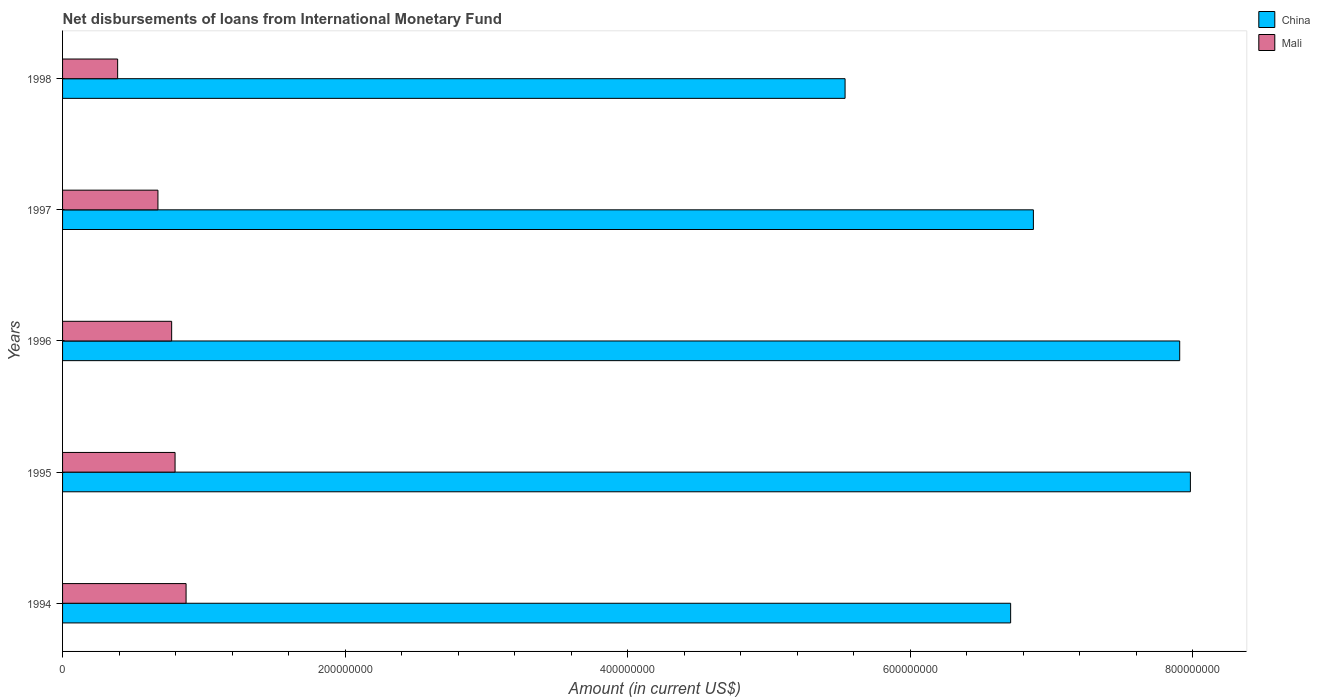How many different coloured bars are there?
Make the answer very short. 2. Are the number of bars per tick equal to the number of legend labels?
Make the answer very short. Yes. Are the number of bars on each tick of the Y-axis equal?
Offer a very short reply. Yes. How many bars are there on the 5th tick from the bottom?
Provide a short and direct response. 2. What is the label of the 1st group of bars from the top?
Offer a very short reply. 1998. What is the amount of loans disbursed in China in 1995?
Your answer should be compact. 7.98e+08. Across all years, what is the maximum amount of loans disbursed in Mali?
Offer a terse response. 8.74e+07. Across all years, what is the minimum amount of loans disbursed in Mali?
Ensure brevity in your answer.  3.90e+07. In which year was the amount of loans disbursed in China maximum?
Offer a very short reply. 1995. What is the total amount of loans disbursed in China in the graph?
Give a very brief answer. 3.50e+09. What is the difference between the amount of loans disbursed in China in 1994 and that in 1997?
Provide a succinct answer. -1.61e+07. What is the difference between the amount of loans disbursed in Mali in 1995 and the amount of loans disbursed in China in 1998?
Your answer should be very brief. -4.74e+08. What is the average amount of loans disbursed in China per year?
Your answer should be compact. 7.00e+08. In the year 1994, what is the difference between the amount of loans disbursed in China and amount of loans disbursed in Mali?
Offer a very short reply. 5.84e+08. In how many years, is the amount of loans disbursed in China greater than 320000000 US$?
Offer a terse response. 5. What is the ratio of the amount of loans disbursed in Mali in 1997 to that in 1998?
Offer a very short reply. 1.73. Is the amount of loans disbursed in China in 1996 less than that in 1998?
Your answer should be very brief. No. What is the difference between the highest and the second highest amount of loans disbursed in China?
Ensure brevity in your answer.  7.57e+06. What is the difference between the highest and the lowest amount of loans disbursed in Mali?
Offer a very short reply. 4.84e+07. In how many years, is the amount of loans disbursed in Mali greater than the average amount of loans disbursed in Mali taken over all years?
Keep it short and to the point. 3. What does the 1st bar from the top in 1996 represents?
Make the answer very short. Mali. What does the 2nd bar from the bottom in 1997 represents?
Offer a very short reply. Mali. Are the values on the major ticks of X-axis written in scientific E-notation?
Your answer should be very brief. No. Does the graph contain any zero values?
Provide a short and direct response. No. Does the graph contain grids?
Ensure brevity in your answer.  No. How many legend labels are there?
Offer a very short reply. 2. How are the legend labels stacked?
Provide a short and direct response. Vertical. What is the title of the graph?
Ensure brevity in your answer.  Net disbursements of loans from International Monetary Fund. Does "Kiribati" appear as one of the legend labels in the graph?
Ensure brevity in your answer.  No. What is the label or title of the Y-axis?
Offer a terse response. Years. What is the Amount (in current US$) of China in 1994?
Provide a succinct answer. 6.71e+08. What is the Amount (in current US$) in Mali in 1994?
Offer a terse response. 8.74e+07. What is the Amount (in current US$) of China in 1995?
Give a very brief answer. 7.98e+08. What is the Amount (in current US$) in Mali in 1995?
Keep it short and to the point. 7.96e+07. What is the Amount (in current US$) of China in 1996?
Provide a short and direct response. 7.91e+08. What is the Amount (in current US$) in Mali in 1996?
Offer a terse response. 7.72e+07. What is the Amount (in current US$) in China in 1997?
Provide a succinct answer. 6.87e+08. What is the Amount (in current US$) of Mali in 1997?
Your response must be concise. 6.75e+07. What is the Amount (in current US$) of China in 1998?
Your response must be concise. 5.54e+08. What is the Amount (in current US$) of Mali in 1998?
Provide a succinct answer. 3.90e+07. Across all years, what is the maximum Amount (in current US$) in China?
Your answer should be compact. 7.98e+08. Across all years, what is the maximum Amount (in current US$) of Mali?
Ensure brevity in your answer.  8.74e+07. Across all years, what is the minimum Amount (in current US$) in China?
Provide a succinct answer. 5.54e+08. Across all years, what is the minimum Amount (in current US$) in Mali?
Make the answer very short. 3.90e+07. What is the total Amount (in current US$) in China in the graph?
Offer a terse response. 3.50e+09. What is the total Amount (in current US$) in Mali in the graph?
Your answer should be very brief. 3.51e+08. What is the difference between the Amount (in current US$) in China in 1994 and that in 1995?
Provide a succinct answer. -1.27e+08. What is the difference between the Amount (in current US$) of Mali in 1994 and that in 1995?
Keep it short and to the point. 7.80e+06. What is the difference between the Amount (in current US$) in China in 1994 and that in 1996?
Keep it short and to the point. -1.20e+08. What is the difference between the Amount (in current US$) of Mali in 1994 and that in 1996?
Provide a succinct answer. 1.02e+07. What is the difference between the Amount (in current US$) in China in 1994 and that in 1997?
Your answer should be compact. -1.61e+07. What is the difference between the Amount (in current US$) of Mali in 1994 and that in 1997?
Ensure brevity in your answer.  1.99e+07. What is the difference between the Amount (in current US$) of China in 1994 and that in 1998?
Provide a succinct answer. 1.17e+08. What is the difference between the Amount (in current US$) of Mali in 1994 and that in 1998?
Make the answer very short. 4.84e+07. What is the difference between the Amount (in current US$) in China in 1995 and that in 1996?
Your answer should be very brief. 7.57e+06. What is the difference between the Amount (in current US$) in Mali in 1995 and that in 1996?
Make the answer very short. 2.41e+06. What is the difference between the Amount (in current US$) in China in 1995 and that in 1997?
Offer a very short reply. 1.11e+08. What is the difference between the Amount (in current US$) of Mali in 1995 and that in 1997?
Provide a succinct answer. 1.21e+07. What is the difference between the Amount (in current US$) of China in 1995 and that in 1998?
Give a very brief answer. 2.44e+08. What is the difference between the Amount (in current US$) in Mali in 1995 and that in 1998?
Provide a short and direct response. 4.06e+07. What is the difference between the Amount (in current US$) of China in 1996 and that in 1997?
Provide a succinct answer. 1.04e+08. What is the difference between the Amount (in current US$) in Mali in 1996 and that in 1997?
Provide a succinct answer. 9.71e+06. What is the difference between the Amount (in current US$) of China in 1996 and that in 1998?
Your answer should be compact. 2.37e+08. What is the difference between the Amount (in current US$) of Mali in 1996 and that in 1998?
Your answer should be very brief. 3.82e+07. What is the difference between the Amount (in current US$) of China in 1997 and that in 1998?
Your response must be concise. 1.33e+08. What is the difference between the Amount (in current US$) in Mali in 1997 and that in 1998?
Ensure brevity in your answer.  2.85e+07. What is the difference between the Amount (in current US$) in China in 1994 and the Amount (in current US$) in Mali in 1995?
Offer a very short reply. 5.91e+08. What is the difference between the Amount (in current US$) in China in 1994 and the Amount (in current US$) in Mali in 1996?
Ensure brevity in your answer.  5.94e+08. What is the difference between the Amount (in current US$) in China in 1994 and the Amount (in current US$) in Mali in 1997?
Give a very brief answer. 6.03e+08. What is the difference between the Amount (in current US$) in China in 1994 and the Amount (in current US$) in Mali in 1998?
Make the answer very short. 6.32e+08. What is the difference between the Amount (in current US$) in China in 1995 and the Amount (in current US$) in Mali in 1996?
Give a very brief answer. 7.21e+08. What is the difference between the Amount (in current US$) in China in 1995 and the Amount (in current US$) in Mali in 1997?
Offer a terse response. 7.31e+08. What is the difference between the Amount (in current US$) in China in 1995 and the Amount (in current US$) in Mali in 1998?
Make the answer very short. 7.59e+08. What is the difference between the Amount (in current US$) of China in 1996 and the Amount (in current US$) of Mali in 1997?
Give a very brief answer. 7.23e+08. What is the difference between the Amount (in current US$) in China in 1996 and the Amount (in current US$) in Mali in 1998?
Provide a short and direct response. 7.52e+08. What is the difference between the Amount (in current US$) in China in 1997 and the Amount (in current US$) in Mali in 1998?
Your answer should be very brief. 6.48e+08. What is the average Amount (in current US$) of China per year?
Make the answer very short. 7.00e+08. What is the average Amount (in current US$) of Mali per year?
Your response must be concise. 7.01e+07. In the year 1994, what is the difference between the Amount (in current US$) in China and Amount (in current US$) in Mali?
Provide a short and direct response. 5.84e+08. In the year 1995, what is the difference between the Amount (in current US$) in China and Amount (in current US$) in Mali?
Provide a succinct answer. 7.19e+08. In the year 1996, what is the difference between the Amount (in current US$) in China and Amount (in current US$) in Mali?
Give a very brief answer. 7.13e+08. In the year 1997, what is the difference between the Amount (in current US$) of China and Amount (in current US$) of Mali?
Give a very brief answer. 6.20e+08. In the year 1998, what is the difference between the Amount (in current US$) in China and Amount (in current US$) in Mali?
Provide a short and direct response. 5.15e+08. What is the ratio of the Amount (in current US$) of China in 1994 to that in 1995?
Offer a very short reply. 0.84. What is the ratio of the Amount (in current US$) of Mali in 1994 to that in 1995?
Make the answer very short. 1.1. What is the ratio of the Amount (in current US$) of China in 1994 to that in 1996?
Your answer should be very brief. 0.85. What is the ratio of the Amount (in current US$) in Mali in 1994 to that in 1996?
Give a very brief answer. 1.13. What is the ratio of the Amount (in current US$) in China in 1994 to that in 1997?
Make the answer very short. 0.98. What is the ratio of the Amount (in current US$) of Mali in 1994 to that in 1997?
Make the answer very short. 1.3. What is the ratio of the Amount (in current US$) of China in 1994 to that in 1998?
Give a very brief answer. 1.21. What is the ratio of the Amount (in current US$) in Mali in 1994 to that in 1998?
Your response must be concise. 2.24. What is the ratio of the Amount (in current US$) in China in 1995 to that in 1996?
Your answer should be very brief. 1.01. What is the ratio of the Amount (in current US$) of Mali in 1995 to that in 1996?
Your answer should be very brief. 1.03. What is the ratio of the Amount (in current US$) in China in 1995 to that in 1997?
Make the answer very short. 1.16. What is the ratio of the Amount (in current US$) in Mali in 1995 to that in 1997?
Offer a terse response. 1.18. What is the ratio of the Amount (in current US$) in China in 1995 to that in 1998?
Your answer should be compact. 1.44. What is the ratio of the Amount (in current US$) in Mali in 1995 to that in 1998?
Keep it short and to the point. 2.04. What is the ratio of the Amount (in current US$) in China in 1996 to that in 1997?
Ensure brevity in your answer.  1.15. What is the ratio of the Amount (in current US$) of Mali in 1996 to that in 1997?
Offer a very short reply. 1.14. What is the ratio of the Amount (in current US$) of China in 1996 to that in 1998?
Your answer should be very brief. 1.43. What is the ratio of the Amount (in current US$) in Mali in 1996 to that in 1998?
Offer a terse response. 1.98. What is the ratio of the Amount (in current US$) of China in 1997 to that in 1998?
Ensure brevity in your answer.  1.24. What is the ratio of the Amount (in current US$) in Mali in 1997 to that in 1998?
Your response must be concise. 1.73. What is the difference between the highest and the second highest Amount (in current US$) in China?
Offer a terse response. 7.57e+06. What is the difference between the highest and the second highest Amount (in current US$) of Mali?
Give a very brief answer. 7.80e+06. What is the difference between the highest and the lowest Amount (in current US$) of China?
Your answer should be compact. 2.44e+08. What is the difference between the highest and the lowest Amount (in current US$) of Mali?
Make the answer very short. 4.84e+07. 